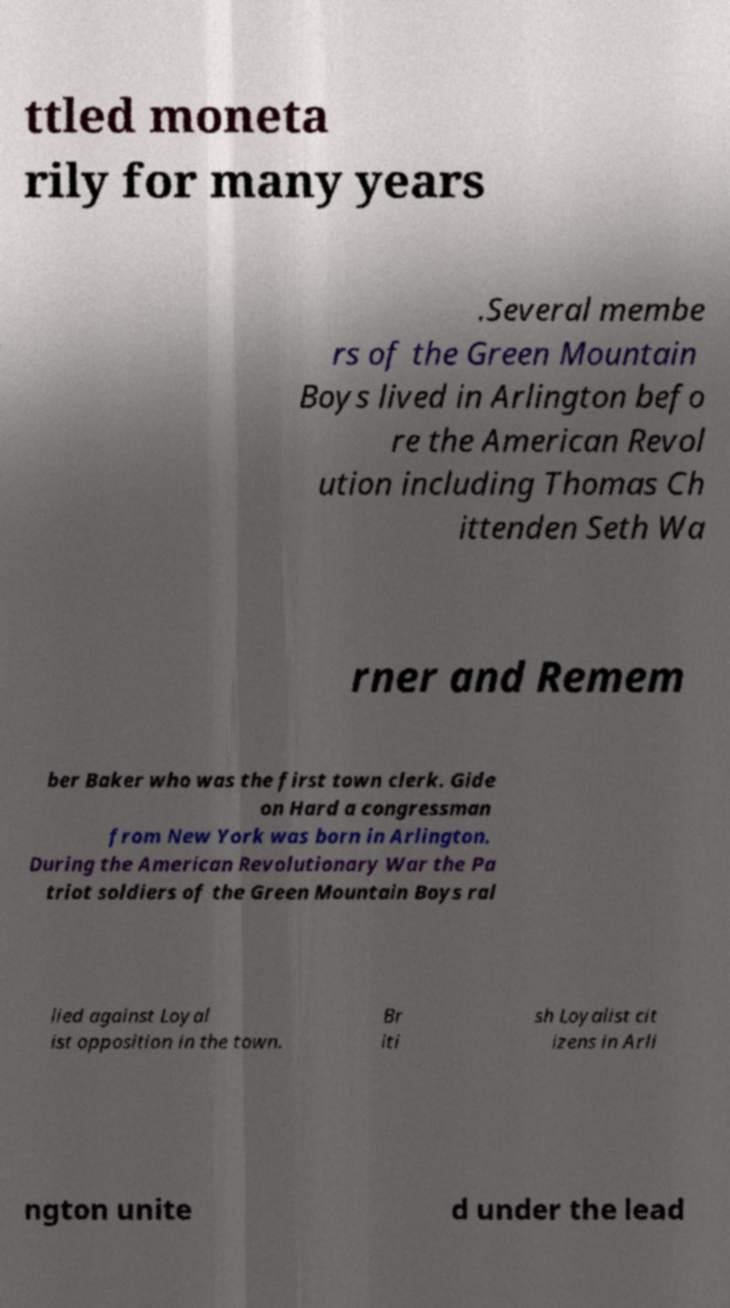Can you accurately transcribe the text from the provided image for me? ttled moneta rily for many years .Several membe rs of the Green Mountain Boys lived in Arlington befo re the American Revol ution including Thomas Ch ittenden Seth Wa rner and Remem ber Baker who was the first town clerk. Gide on Hard a congressman from New York was born in Arlington. During the American Revolutionary War the Pa triot soldiers of the Green Mountain Boys ral lied against Loyal ist opposition in the town. Br iti sh Loyalist cit izens in Arli ngton unite d under the lead 